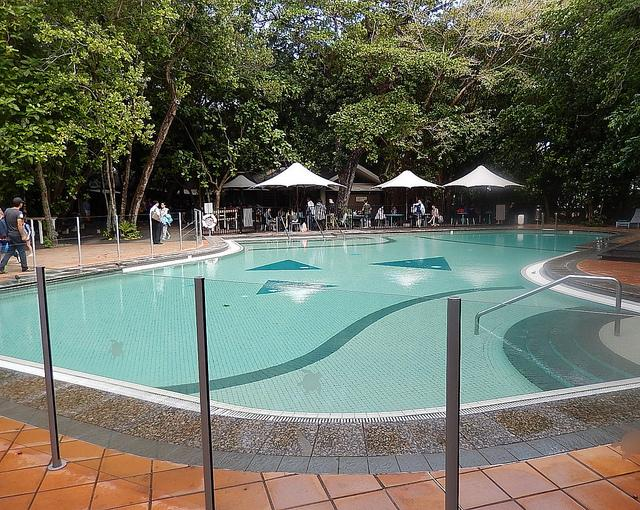What is the far end of the pool called?

Choices:
A) deep side
B) adults only
C) deep zone
D) deep end deep end 